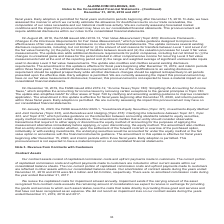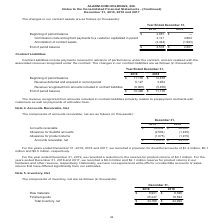According to Alarmcom Holdings's financial document, What does the company's contract assets consist of? capitalized commission costs and upfront payments made to customers.. The document states: "Our contract assets consist of capitalized commission costs and upfront payments made to customers. The current portion of capitalized commission cost..." Also, Where does the company include the non-current portion of capitalized commission costs and upfront payments made to customers in their consolidated balance sheets? According to the financial document, other assets. The relevant text states: "front payments made to customers are reflected in other assets within our consolidated balance sheets. Our amortization of contract assets during the years ended..." Also, What was the Commission costs and upfront payments to a customer capitalized in period in 2019? According to the financial document, 4,141 (in thousands). The relevant text states: "ront payments to a customer capitalized in period 4,141 4,864 Amortization of contract assets (2,444) (1,983) End of period balance $ 4,578 $ 2,881..." Also, can you calculate: What was the change between the beginning of period balance and end of period balance in 2019? Based on the calculation: 4,578-2,881, the result is 1697 (in thousands). This is based on the information: "ct assets (2,444) (1,983) End of period balance $ 4,578 $ 2,881 ember 31, 2019 2018 Beginning of period balance $ 2,881 $ — Commission costs and upfront payments to a customer capitalized in period 4,..." The key data points involved are: 2,881, 4,578. Also, How many years did Commission costs and upfront payments to a customer capitalized in period exceed $4,500 thousand? Based on the analysis, there are 1 instances. The counting process: 2018. Also, can you calculate: What was the percentage change in the Amortization of contract assets between 2018 and 2019? To answer this question, I need to perform calculations using the financial data. The calculation is: (-2,444+1,983)/-1,983, which equals 23.25 (percentage). This is based on the information: "riod 4,141 4,864 Amortization of contract assets (2,444) (1,983) End of period balance $ 4,578 $ 2,881 41 4,864 Amortization of contract assets (2,444) (1,983) End of period balance $ 4,578 $ 2,881..." The key data points involved are: 1,983, 2,444. 